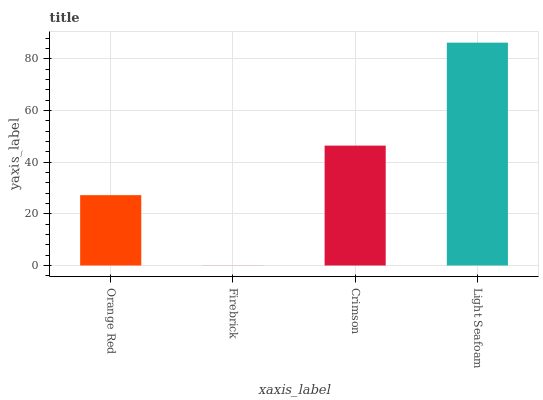Is Firebrick the minimum?
Answer yes or no. Yes. Is Light Seafoam the maximum?
Answer yes or no. Yes. Is Crimson the minimum?
Answer yes or no. No. Is Crimson the maximum?
Answer yes or no. No. Is Crimson greater than Firebrick?
Answer yes or no. Yes. Is Firebrick less than Crimson?
Answer yes or no. Yes. Is Firebrick greater than Crimson?
Answer yes or no. No. Is Crimson less than Firebrick?
Answer yes or no. No. Is Crimson the high median?
Answer yes or no. Yes. Is Orange Red the low median?
Answer yes or no. Yes. Is Orange Red the high median?
Answer yes or no. No. Is Firebrick the low median?
Answer yes or no. No. 